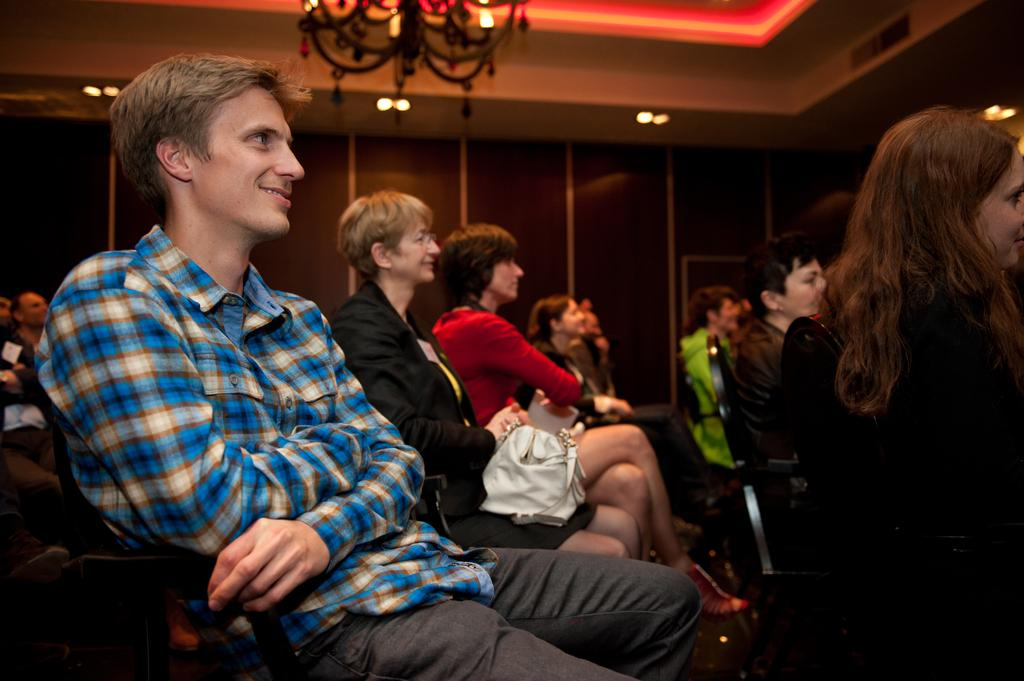What are the people in the foreground of the image doing? The people are sitting on chairs in the foreground of the image. What type of lighting fixture can be seen in the image? There is a chandelier visible in the image. What part of a building is present in the image? The roof is present in the image. What is providing illumination in the image? Lights are visible in the image. What letters are the people writing to their father while taking a bath in the image? There is no reference to letters, a father, or a bath in the image; it only shows people sitting on chairs and other architectural elements. 